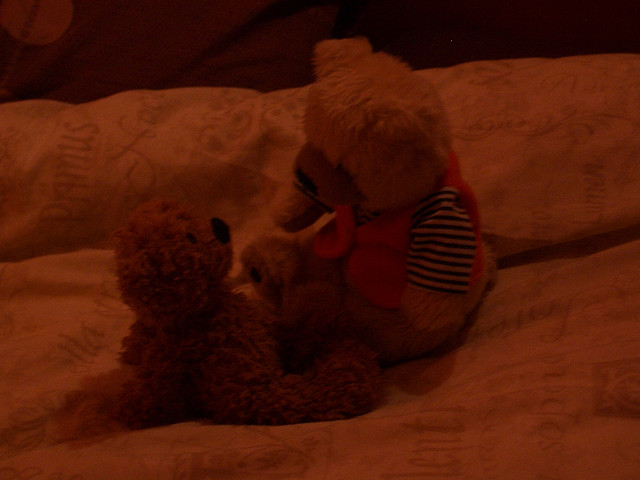<image>Why is the room red? It is unknown why the room is red. However, it could be due to lighting or a red light bulb. Why is the room red? I don't know why the room is red. It could be because of mood lighting, a red light bulb, or some other type of lighting. 